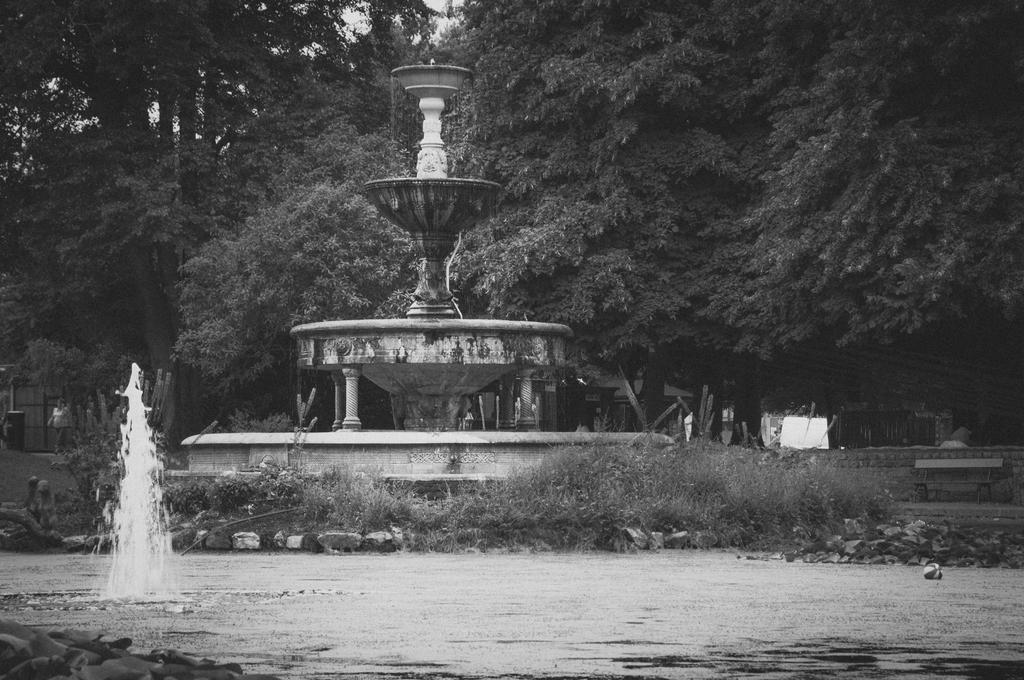What is located in the foreground of the image? There is a water body in the foreground of the image. What can be seen in the background of the image? There are trees and a monument in the background of the image. What are the people in the image doing? The people in the image are walking. What type of surface is present in the image? There are stones present in the image. What invention is being demonstrated by the people in the image? There is no invention being demonstrated in the image; people are simply walking. What type of arm is visible in the image? There is no specific arm visible in the image; it features a water body, trees, a monument, people walking, and stones. 